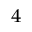Convert formula to latex. <formula><loc_0><loc_0><loc_500><loc_500>^ { 4 }</formula> 